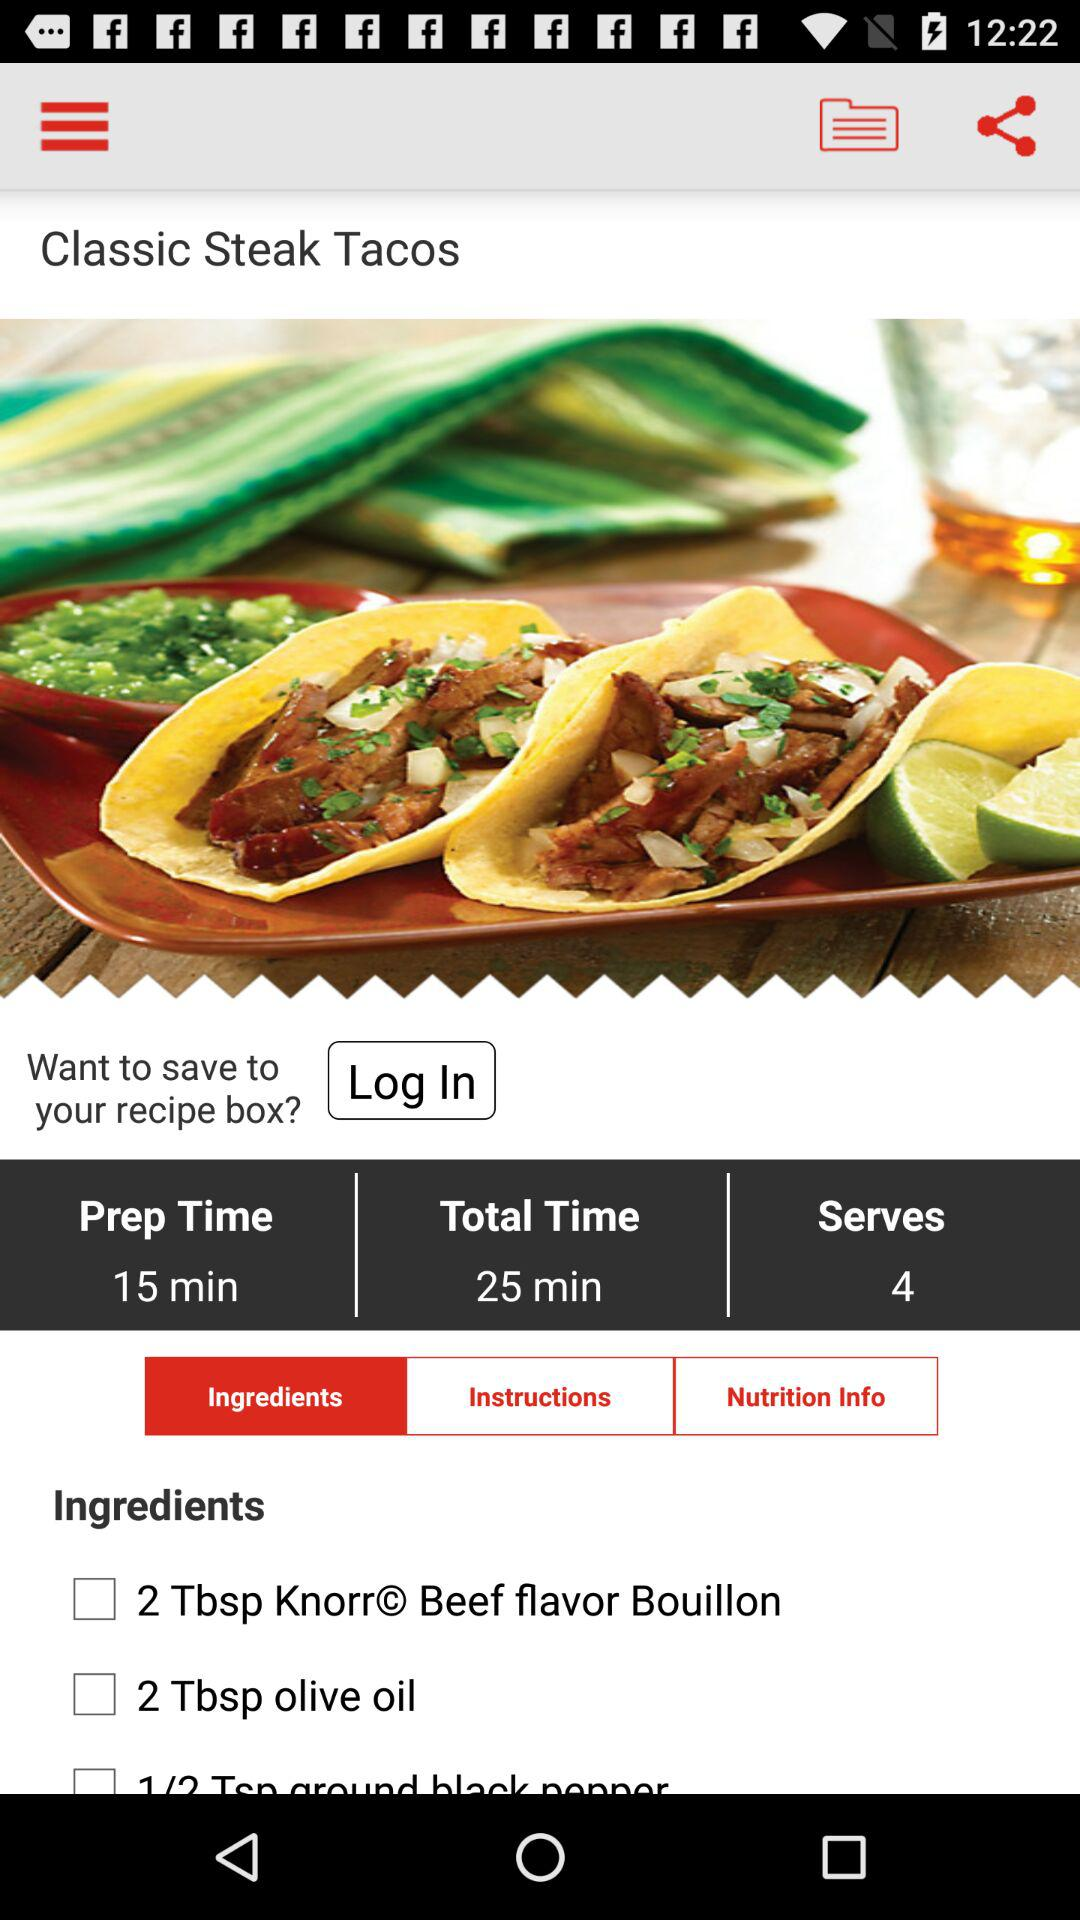How many servings in total are there? There are 4 servings in total. 